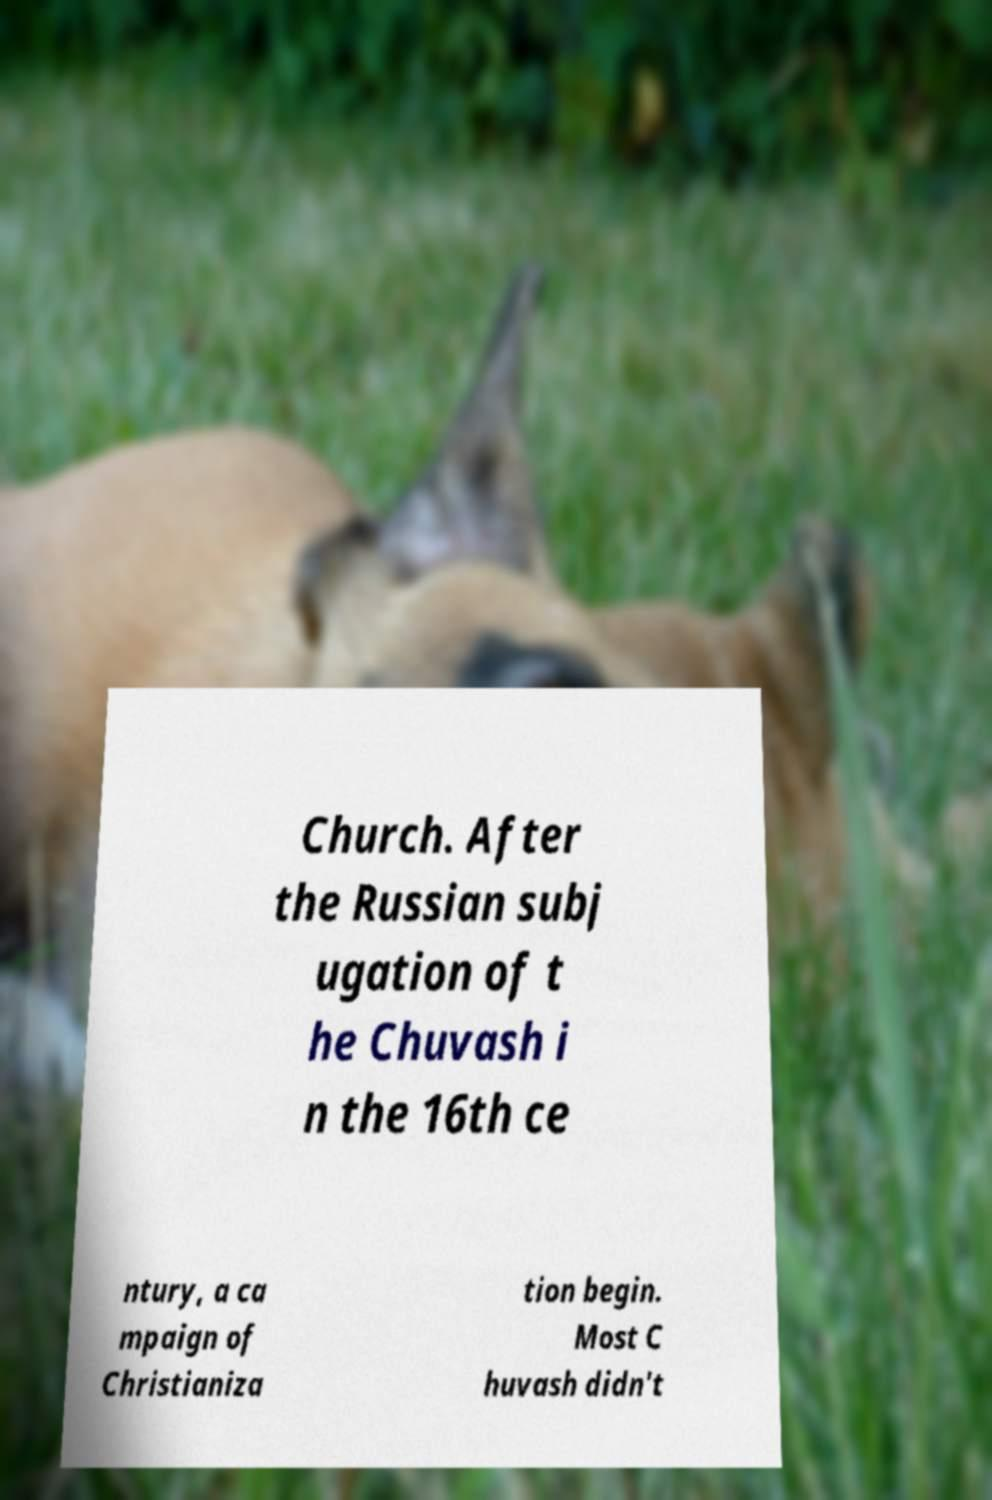Could you assist in decoding the text presented in this image and type it out clearly? Church. After the Russian subj ugation of t he Chuvash i n the 16th ce ntury, a ca mpaign of Christianiza tion begin. Most C huvash didn't 